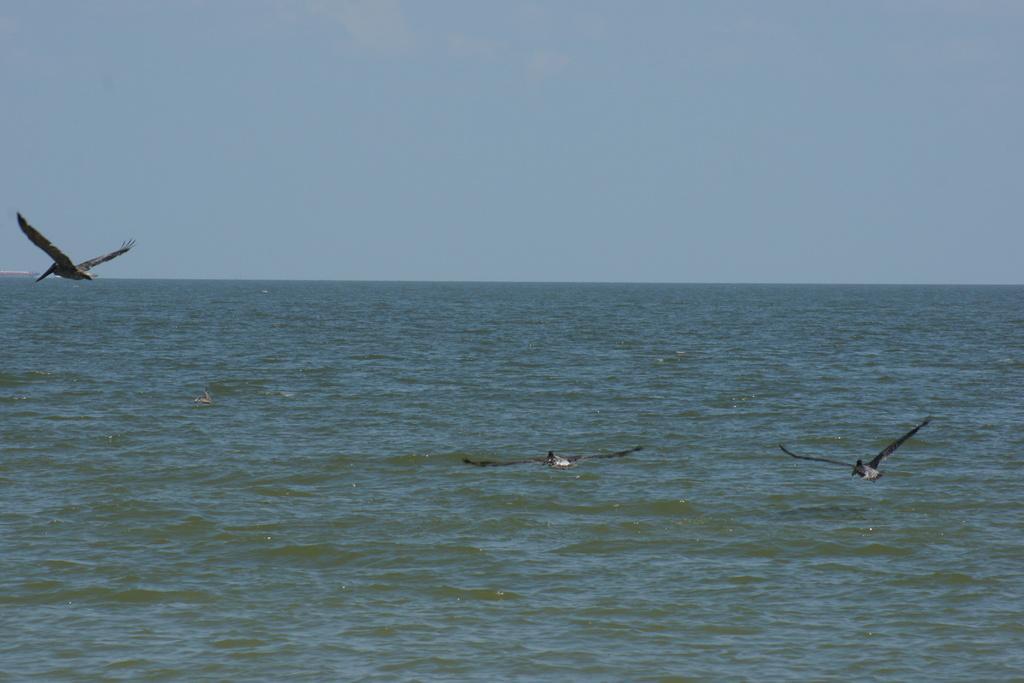How would you summarize this image in a sentence or two? In the middle of the image few birds are flying. Behind the birds there is water and sky. 